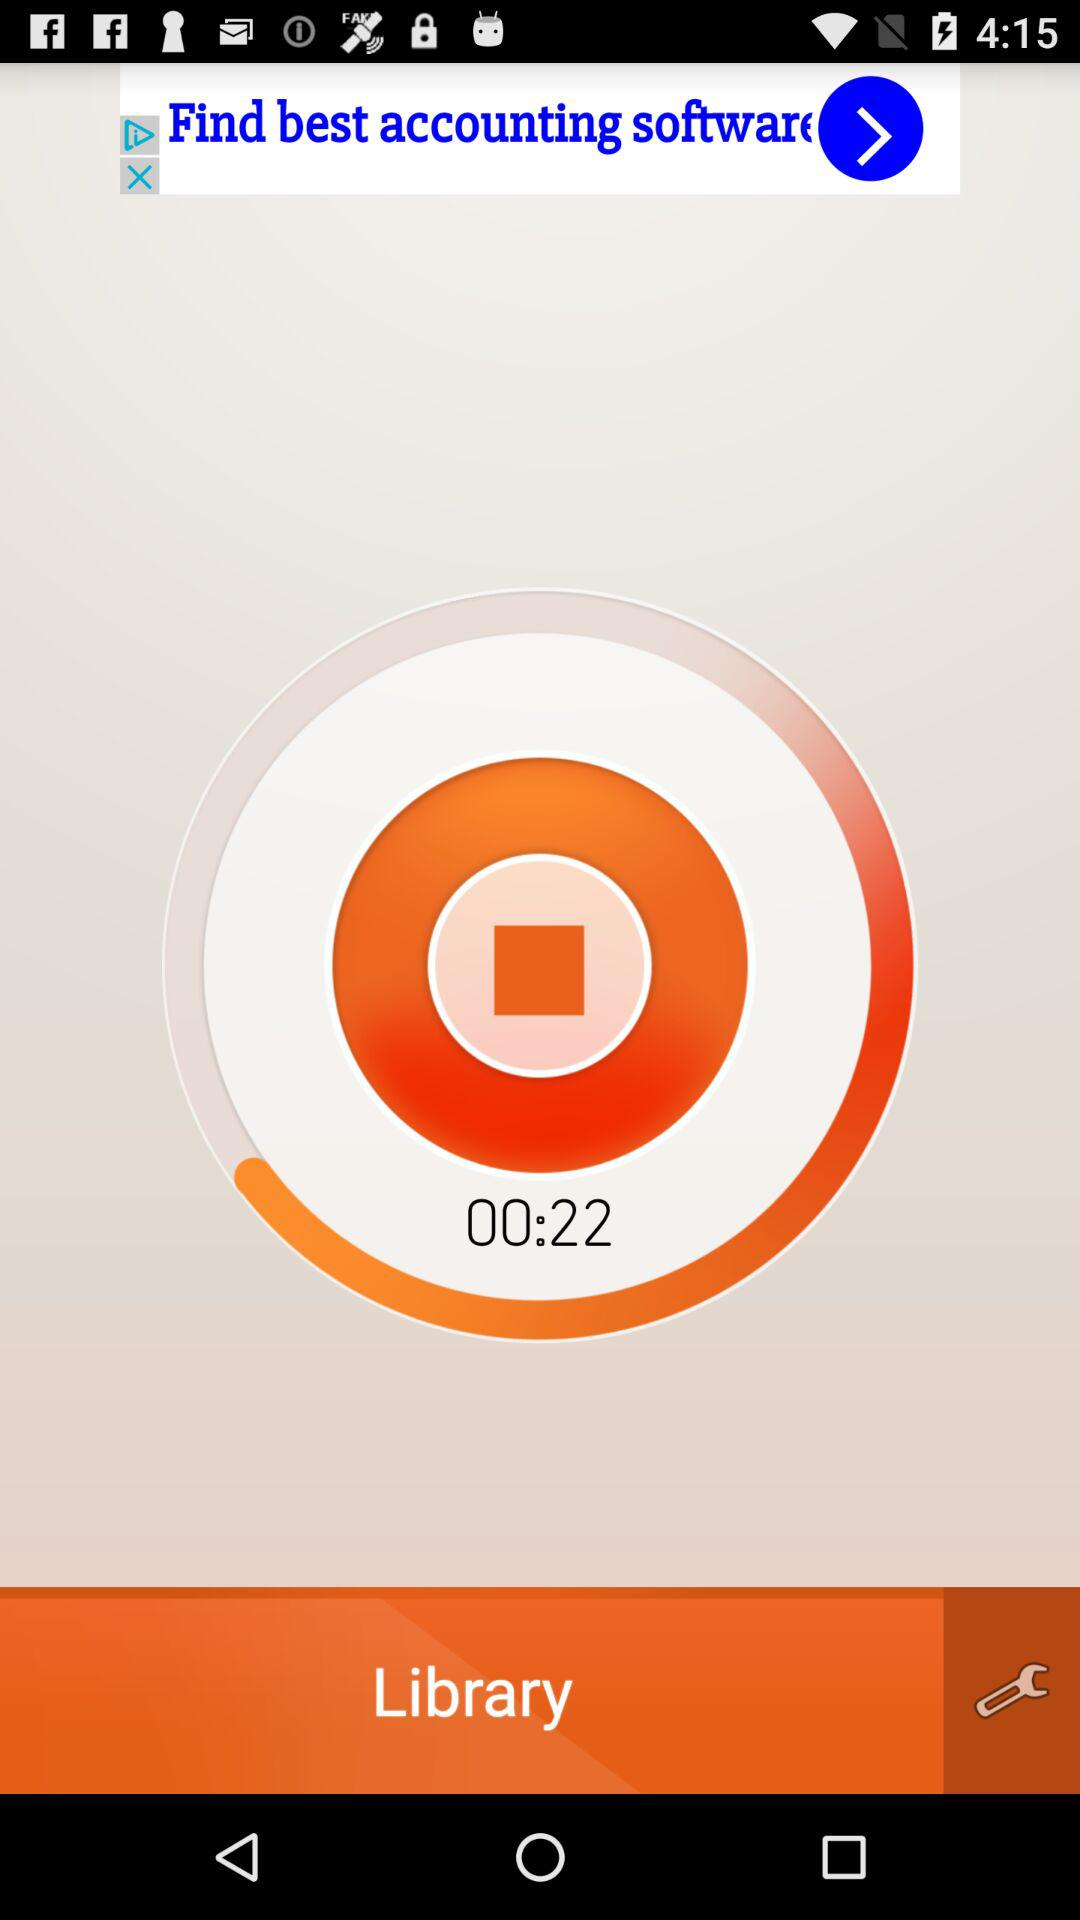How long is the video?
Answer the question using a single word or phrase. 00:22 